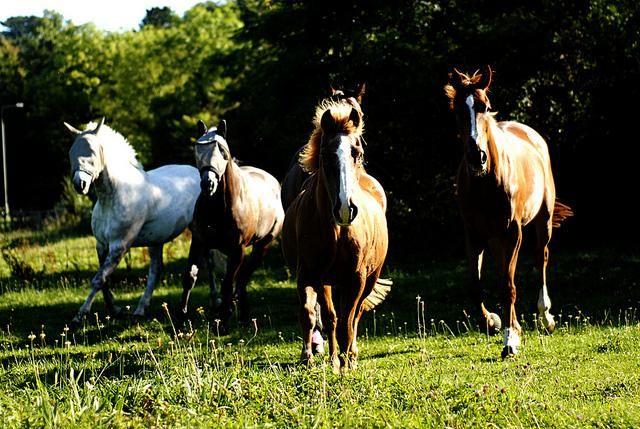These animals are known to do what? run 